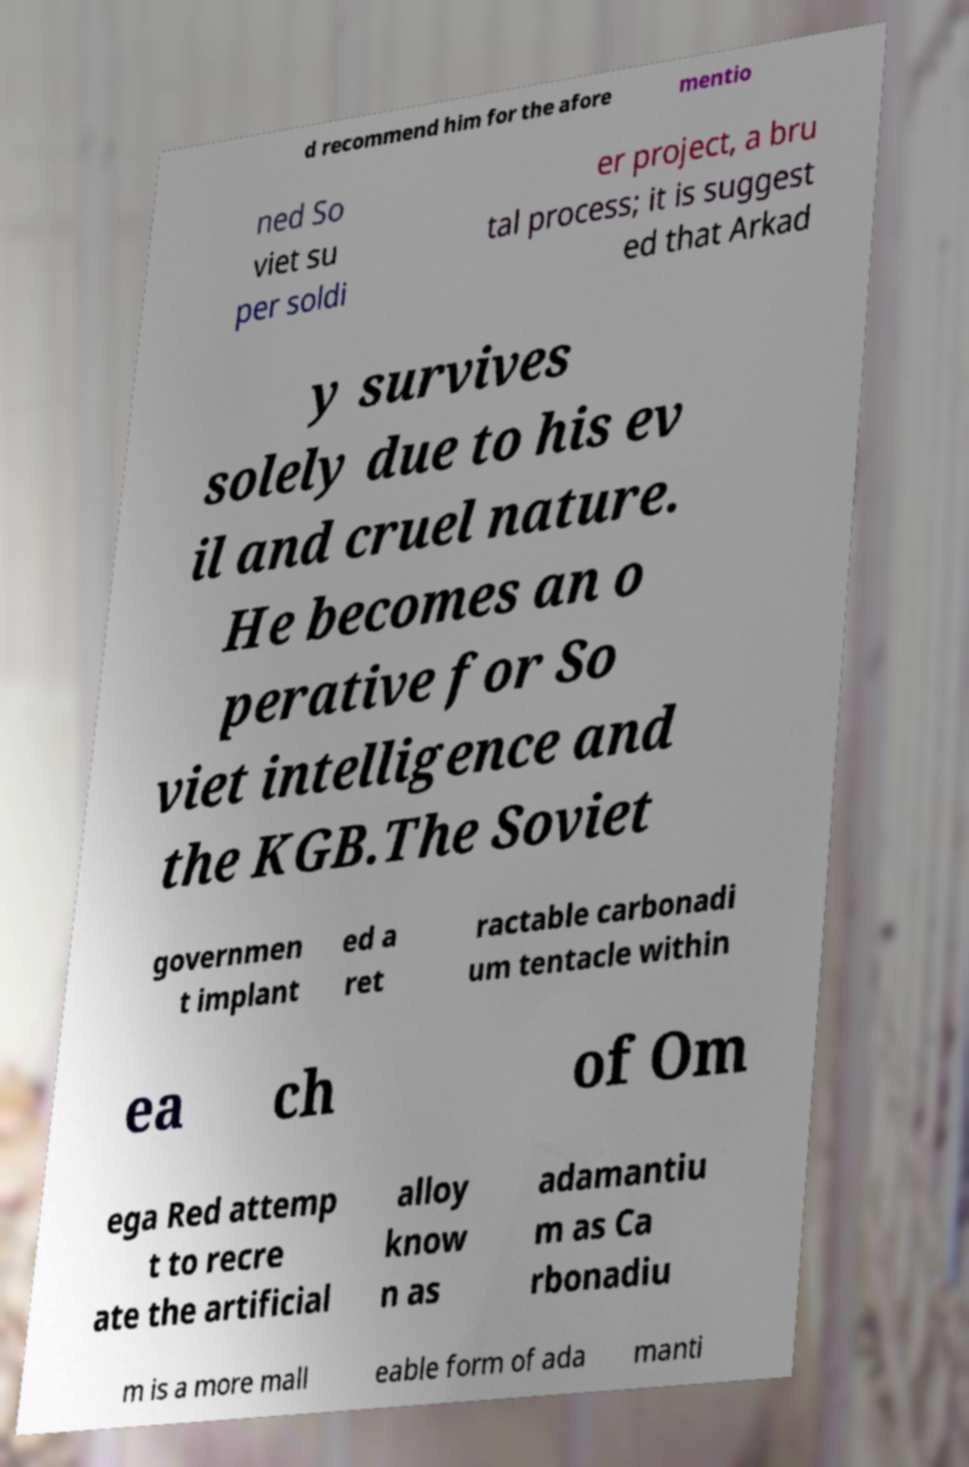Could you assist in decoding the text presented in this image and type it out clearly? d recommend him for the afore mentio ned So viet su per soldi er project, a bru tal process; it is suggest ed that Arkad y survives solely due to his ev il and cruel nature. He becomes an o perative for So viet intelligence and the KGB.The Soviet governmen t implant ed a ret ractable carbonadi um tentacle within ea ch of Om ega Red attemp t to recre ate the artificial alloy know n as adamantiu m as Ca rbonadiu m is a more mall eable form of ada manti 